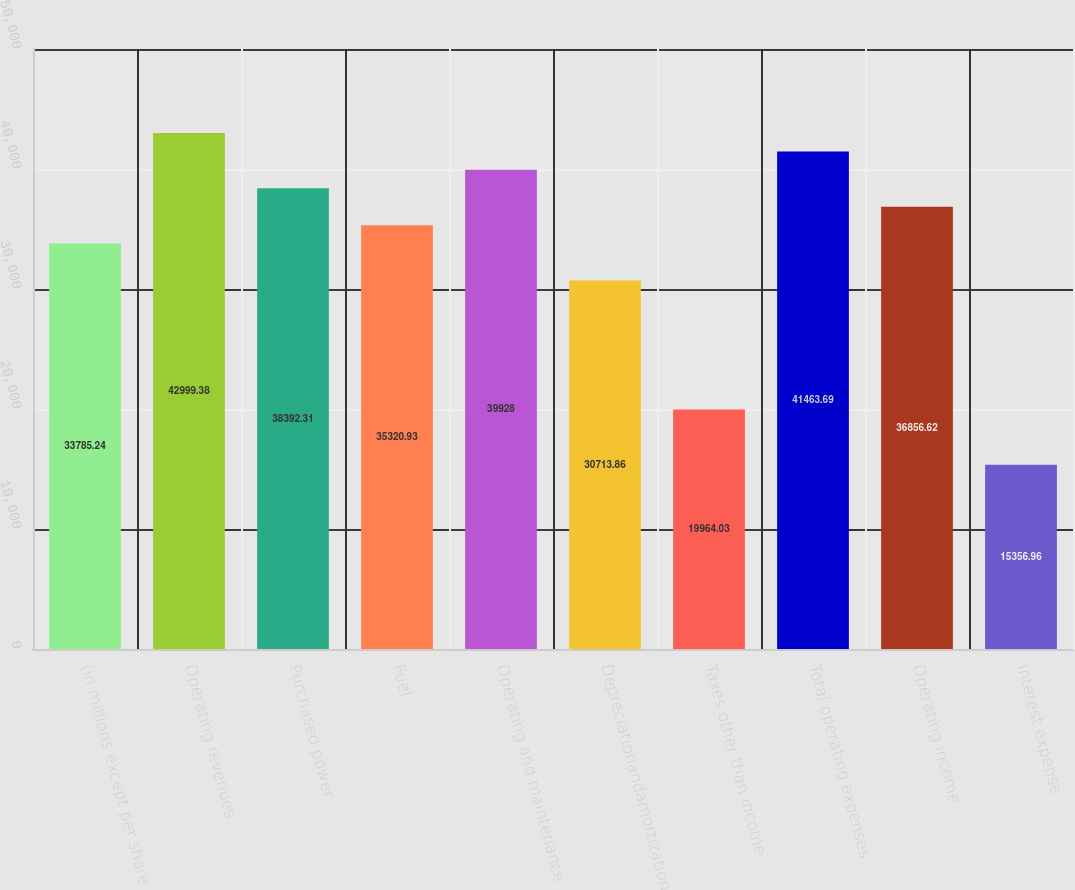Convert chart to OTSL. <chart><loc_0><loc_0><loc_500><loc_500><bar_chart><fcel>(in millions except per share<fcel>Operating revenues<fcel>Purchased power<fcel>Fuel<fcel>Operating and maintenance<fcel>Depreciationandamortization<fcel>Taxes other than income<fcel>Total operating expenses<fcel>Operating income<fcel>Interest expense<nl><fcel>33785.2<fcel>42999.4<fcel>38392.3<fcel>35320.9<fcel>39928<fcel>30713.9<fcel>19964<fcel>41463.7<fcel>36856.6<fcel>15357<nl></chart> 